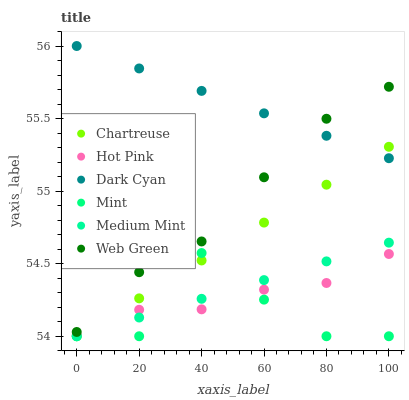Does Mint have the minimum area under the curve?
Answer yes or no. Yes. Does Dark Cyan have the maximum area under the curve?
Answer yes or no. Yes. Does Hot Pink have the minimum area under the curve?
Answer yes or no. No. Does Hot Pink have the maximum area under the curve?
Answer yes or no. No. Is Dark Cyan the smoothest?
Answer yes or no. Yes. Is Mint the roughest?
Answer yes or no. Yes. Is Hot Pink the smoothest?
Answer yes or no. No. Is Hot Pink the roughest?
Answer yes or no. No. Does Medium Mint have the lowest value?
Answer yes or no. Yes. Does Hot Pink have the lowest value?
Answer yes or no. No. Does Dark Cyan have the highest value?
Answer yes or no. Yes. Does Web Green have the highest value?
Answer yes or no. No. Is Medium Mint less than Web Green?
Answer yes or no. Yes. Is Web Green greater than Medium Mint?
Answer yes or no. Yes. Does Medium Mint intersect Chartreuse?
Answer yes or no. Yes. Is Medium Mint less than Chartreuse?
Answer yes or no. No. Is Medium Mint greater than Chartreuse?
Answer yes or no. No. Does Medium Mint intersect Web Green?
Answer yes or no. No. 